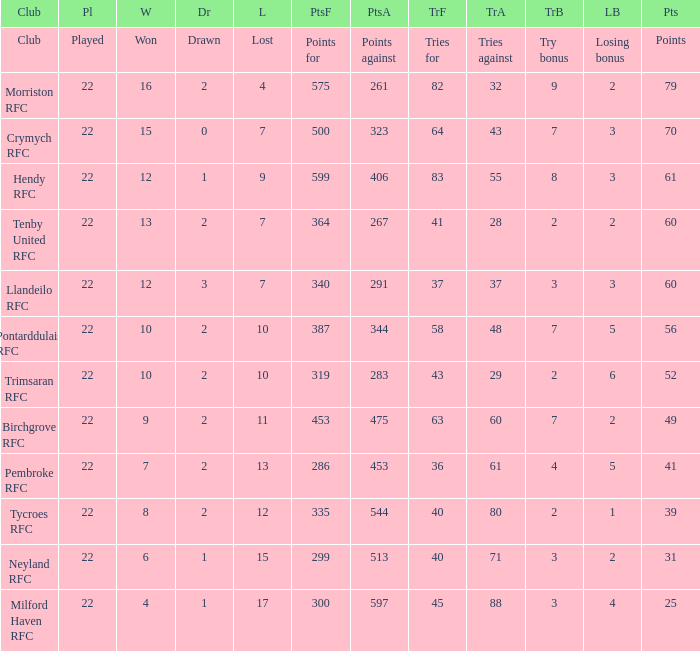What's the won with points against being 597 4.0. 